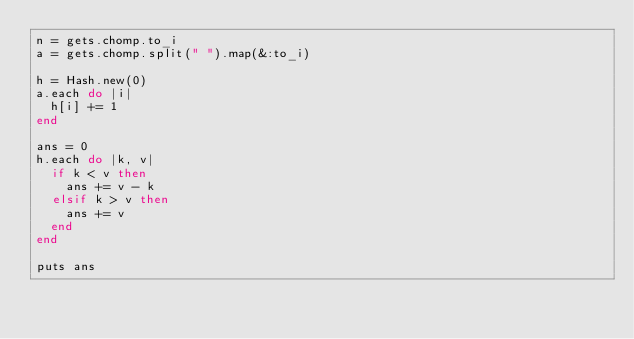<code> <loc_0><loc_0><loc_500><loc_500><_Ruby_>n = gets.chomp.to_i
a = gets.chomp.split(" ").map(&:to_i)

h = Hash.new(0)
a.each do |i|
  h[i] += 1
end

ans = 0
h.each do |k, v|
  if k < v then
    ans += v - k
  elsif k > v then
    ans += v
  end
end

puts ans</code> 